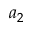<formula> <loc_0><loc_0><loc_500><loc_500>a _ { 2 }</formula> 